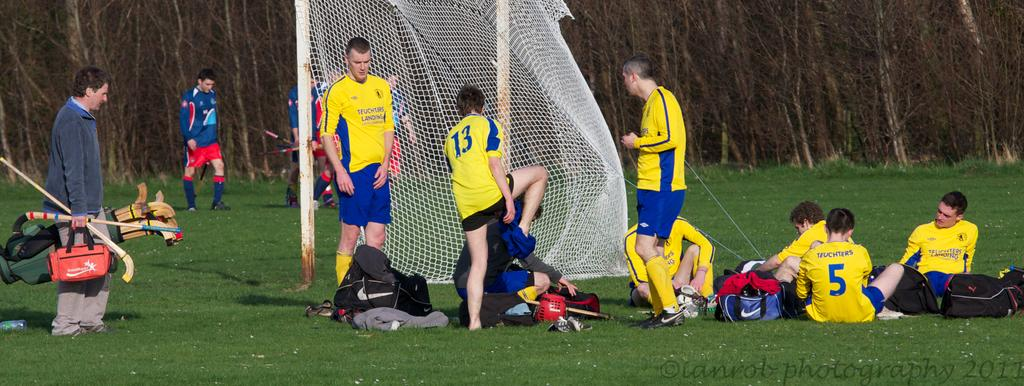<image>
Give a short and clear explanation of the subsequent image. Teuchters is the team name displayed on the back of these jerseys. 